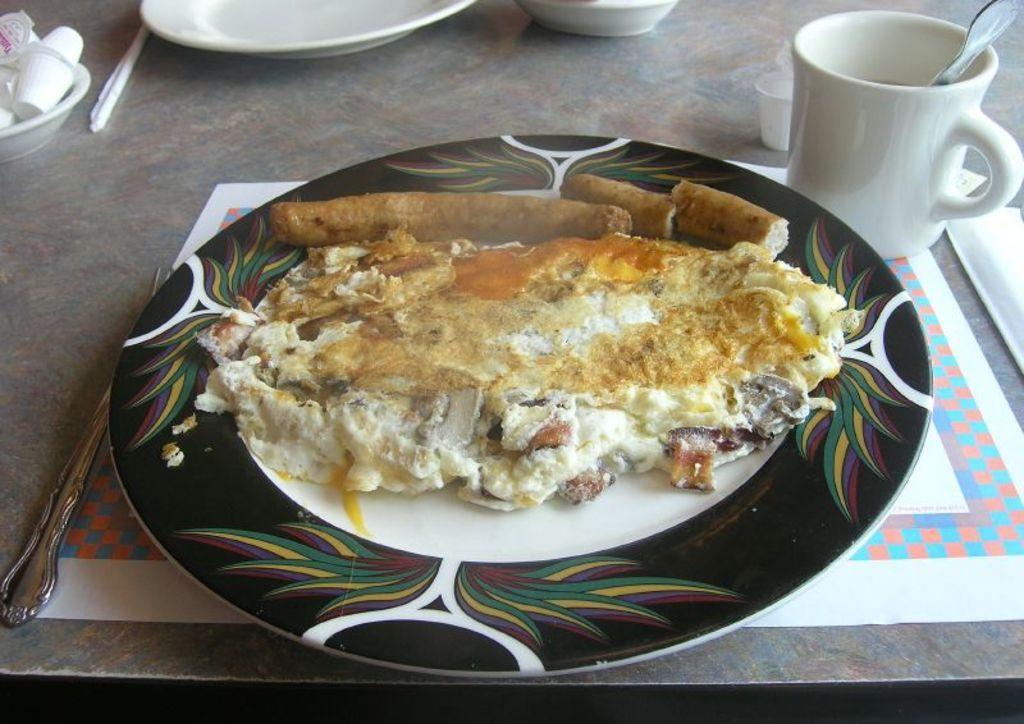Could you give a brief overview of what you see in this image? In this picture we can observe some food places in the plate. The plate is in white and black color. We can observe a table on which a plate was placed. There is a cup which is in white color on the right side. 